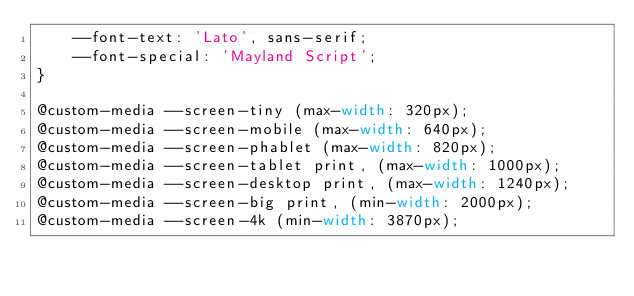<code> <loc_0><loc_0><loc_500><loc_500><_CSS_>	--font-text: 'Lato', sans-serif;
	--font-special: 'Mayland Script';
}

@custom-media --screen-tiny (max-width: 320px);
@custom-media --screen-mobile (max-width: 640px);
@custom-media --screen-phablet (max-width: 820px);
@custom-media --screen-tablet print, (max-width: 1000px);
@custom-media --screen-desktop print, (max-width: 1240px);
@custom-media --screen-big print, (min-width: 2000px);
@custom-media --screen-4k (min-width: 3870px);</code> 